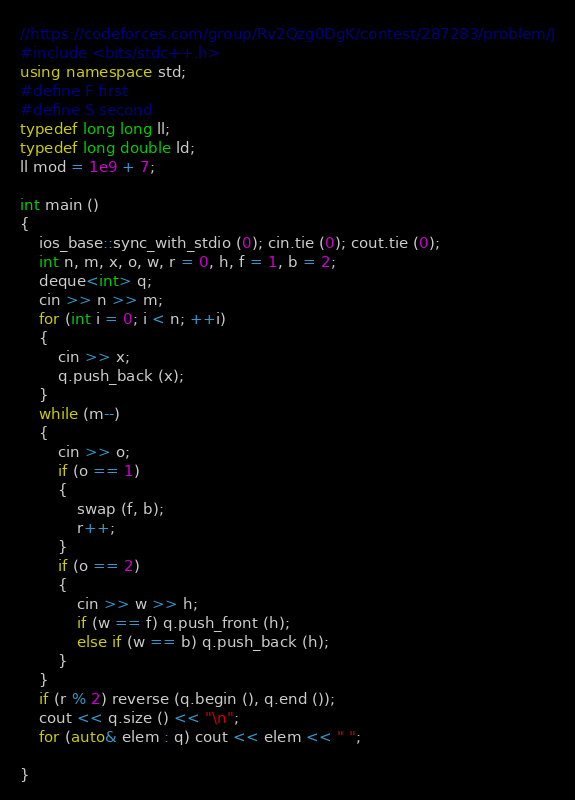Convert code to text. <code><loc_0><loc_0><loc_500><loc_500><_C++_>//https://codeforces.com/group/Rv2Qzg0DgK/contest/287283/problem/J
#include <bits/stdc++.h>
using namespace std;
#define F first 
#define S second
typedef long long ll;
typedef long double ld;
ll mod = 1e9 + 7;

int main ()
{
	ios_base::sync_with_stdio (0); cin.tie (0); cout.tie (0);
    int n, m, x, o, w, r = 0, h, f = 1, b = 2;
    deque<int> q;
    cin >> n >> m;
    for (int i = 0; i < n; ++i)
    {
        cin >> x;
        q.push_back (x);
    }
    while (m--)
    {
        cin >> o;
        if (o == 1)
        {
            swap (f, b);
            r++;
        }
        if (o == 2)
        {
            cin >> w >> h;
            if (w == f) q.push_front (h);
            else if (w == b) q.push_back (h);
        }
    }
    if (r % 2) reverse (q.begin (), q.end ());
    cout << q.size () << "\n";
    for (auto& elem : q) cout << elem << " ";

}

</code> 